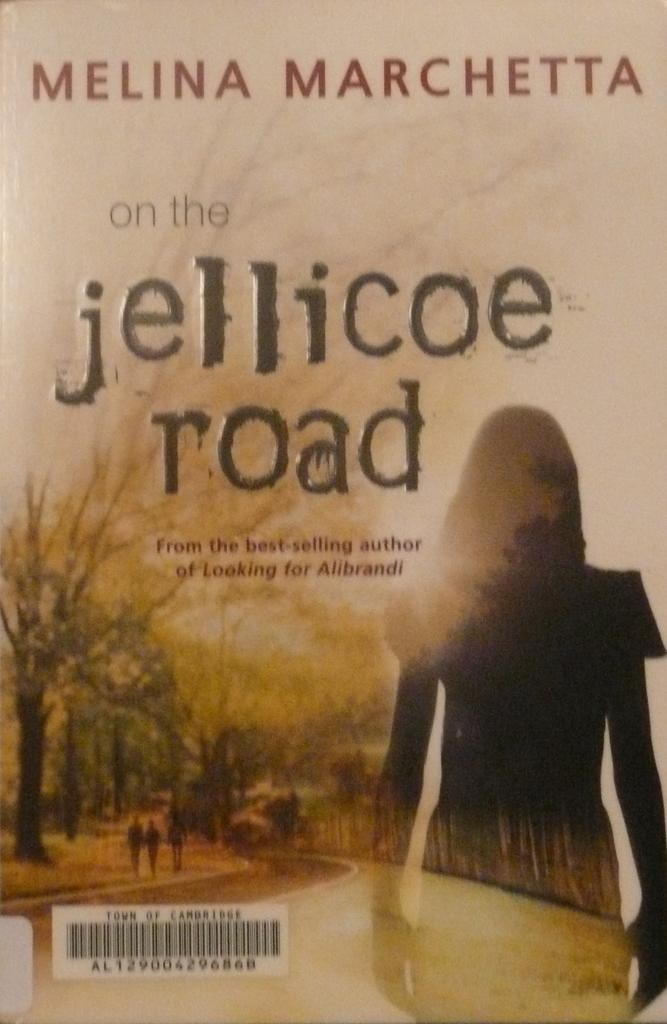Provide a one-sentence caption for the provided image. A paperback book is written by a best selling author named Melina Marchetta. 